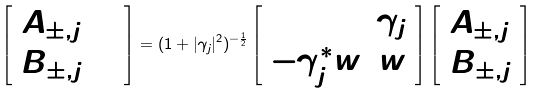<formula> <loc_0><loc_0><loc_500><loc_500>\left [ \begin{array} { c } A _ { \pm , j + 1 } \\ B _ { \pm , j + 1 } \end{array} \right ] = ( 1 + | \gamma _ { j } | ^ { 2 } ) ^ { - \frac { 1 } { 2 } } \left [ \begin{array} { c c } 1 & \gamma _ { j } \\ - \gamma _ { j } ^ { * } w & w \end{array} \right ] \left [ \begin{array} { c } A _ { \pm , j } \\ B _ { \pm , j } \end{array} \right ]</formula> 